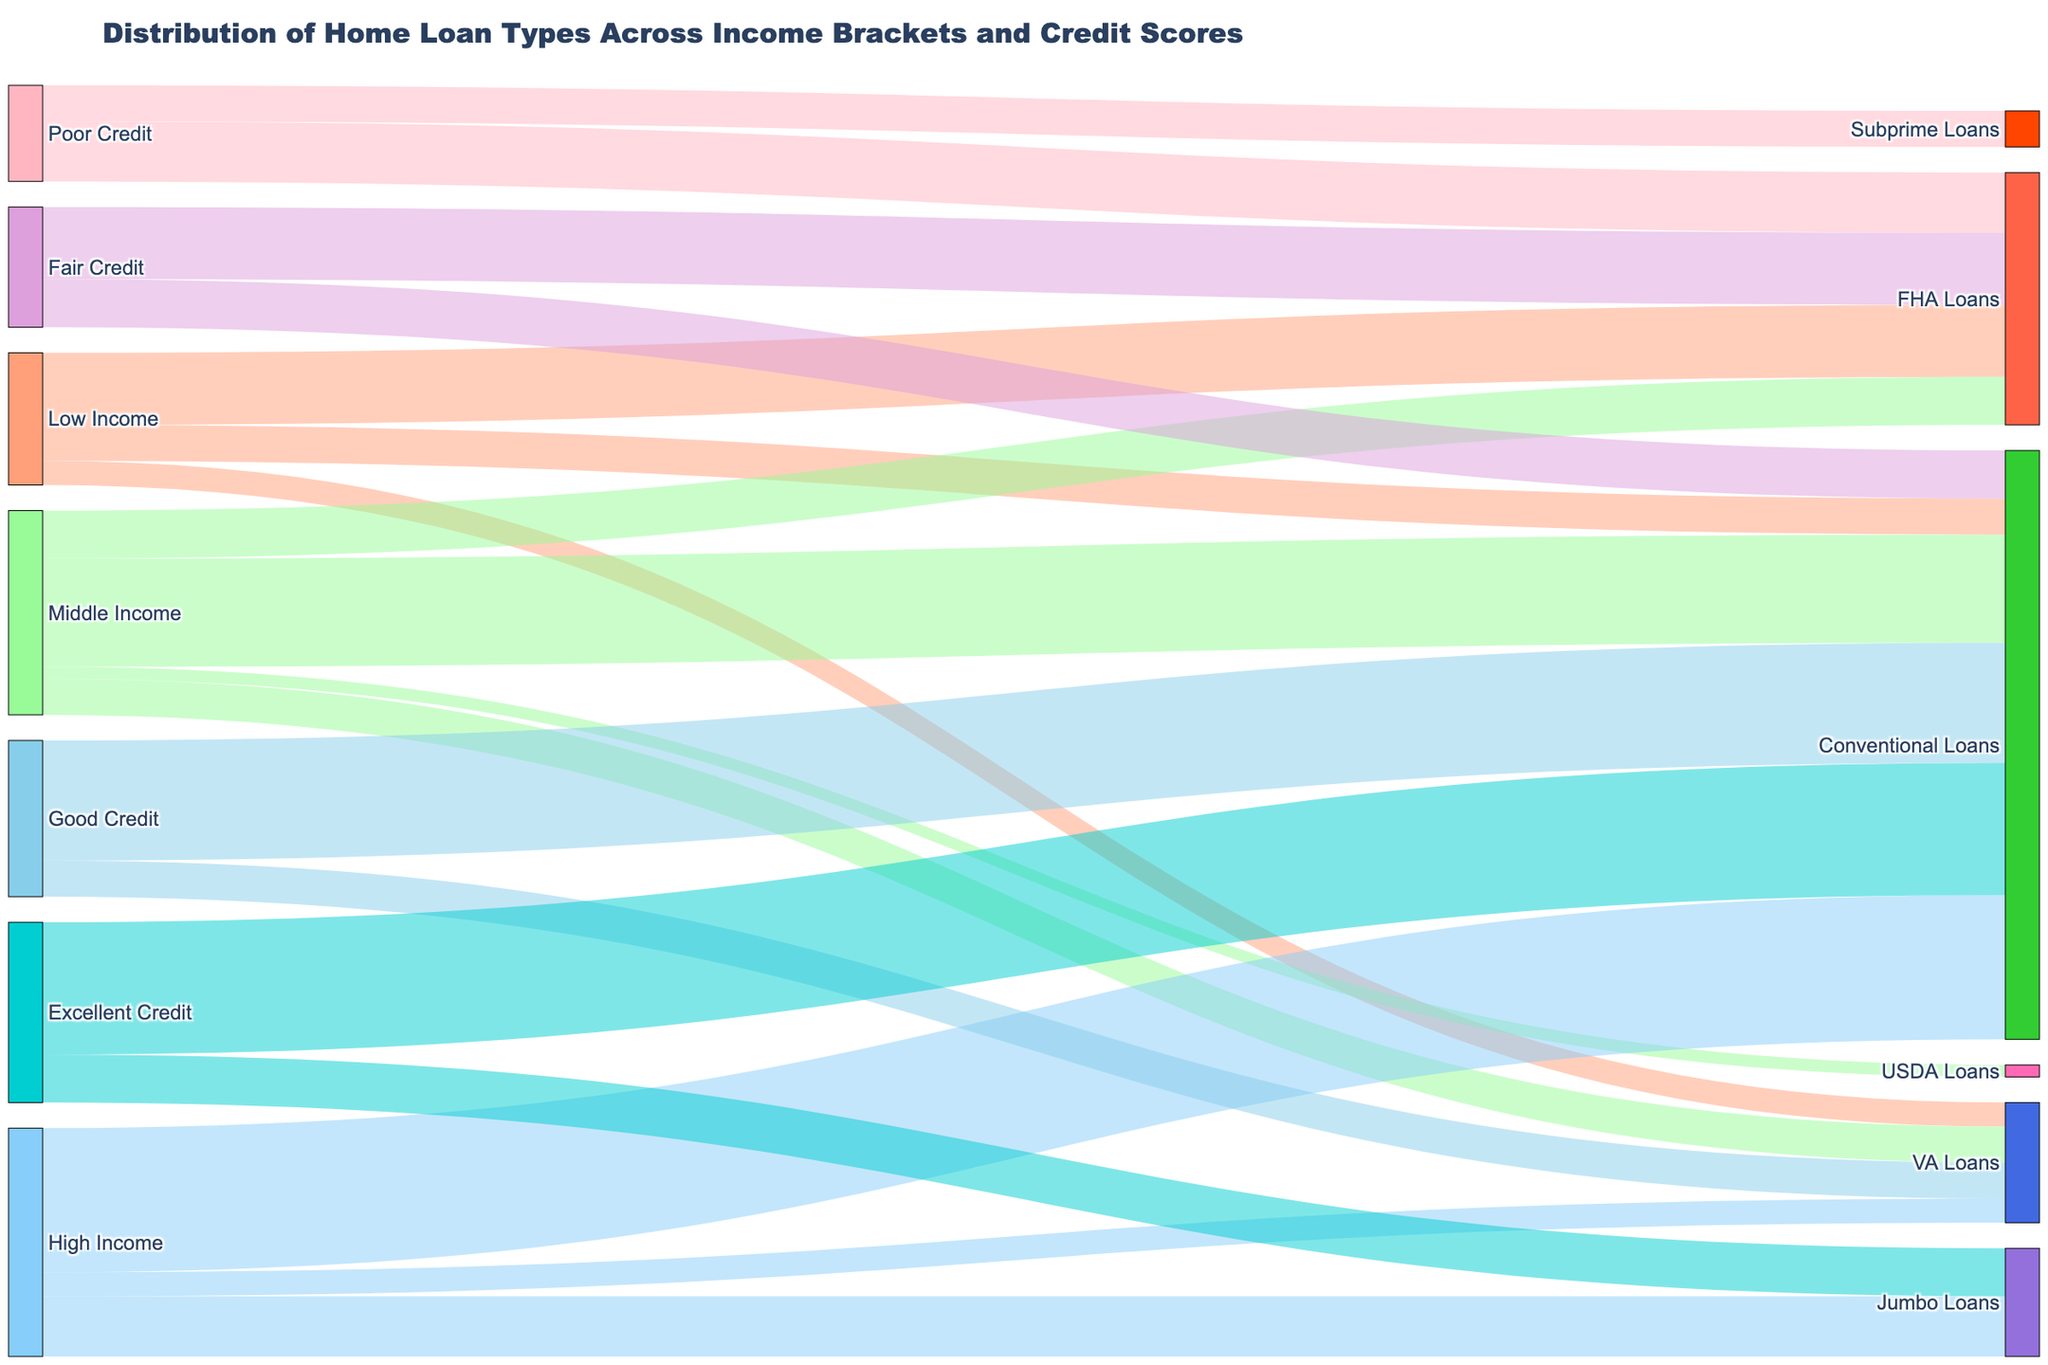What is the title of the figure? The title is located at the top of the figure and describes what the figure is about.
Answer: Distribution of Home Loan Types Across Income Brackets and Credit Scores What color is used to represent the 'Low Income' category? The colors used in the figure are labeled with the income brackets and credit scores. The color for 'Low Income' is found closely in the legend or by reviewing the labeled connections.
Answer: Light Salmon Which loan type is most common among high-income individuals? Check the highest value connecting high-income individuals to various loan types. The thickest line from 'High Income' indicates the most common loan type.
Answer: Conventional Loans How many types of home loans are taken by middle-income individuals? Count the number of distinct loan types connected to 'Middle Income' in the diagram. Each loan type will have a separate line connected to 'Middle Income'.
Answer: 4 What is the total number of loans taken by individuals with excellent credit? Sum the values of all loan types connected to 'Excellent Credit' by identifying the corresponding values in the figure.
Answer: 75 Which credit score category has the smallest proportion of FHA loans? Compare the values connecting all credit score categories to FHA loans and identify the smallest one.
Answer: Poor Credit How does the distribution of loan types differ between excellent credit scores and good credit scores? Compare the values and types of loans taken by both categories by reviewing the lines and their thickness. Good credit scorers predominantly take conventional and VA loans while excellent credit scorers tend to choose conventional and jumbo loans, with a higher preference for conventional loans.
Answer: Excellent Credit prefers Conventional and Jumbo Loans with a higher value, whereas Good Credit prefers Conventional and VA Loans What proportion of low-income individuals opt for Conventional Loans compared to FHA Loans? Look at the values connecting 'Low Income' to 'Conventional Loans' and 'FHA Loans'. Calculate the proportion as the value of Conventional Loans divided by the value of FHA Loans.
Answer: 0.5 (15/30) Which group has a higher number of VA loans – High Income or Middle Income? Compare the values of VA loans between 'High Income' and 'Middle Income' by identifying the connecting lines and their values.
Answer: Middle Income How many loan types are offered to individuals with fair credit scores? Count the distinct loan types connected to 'Fair Credit' by following the lines in the diagram.
Answer: 2 